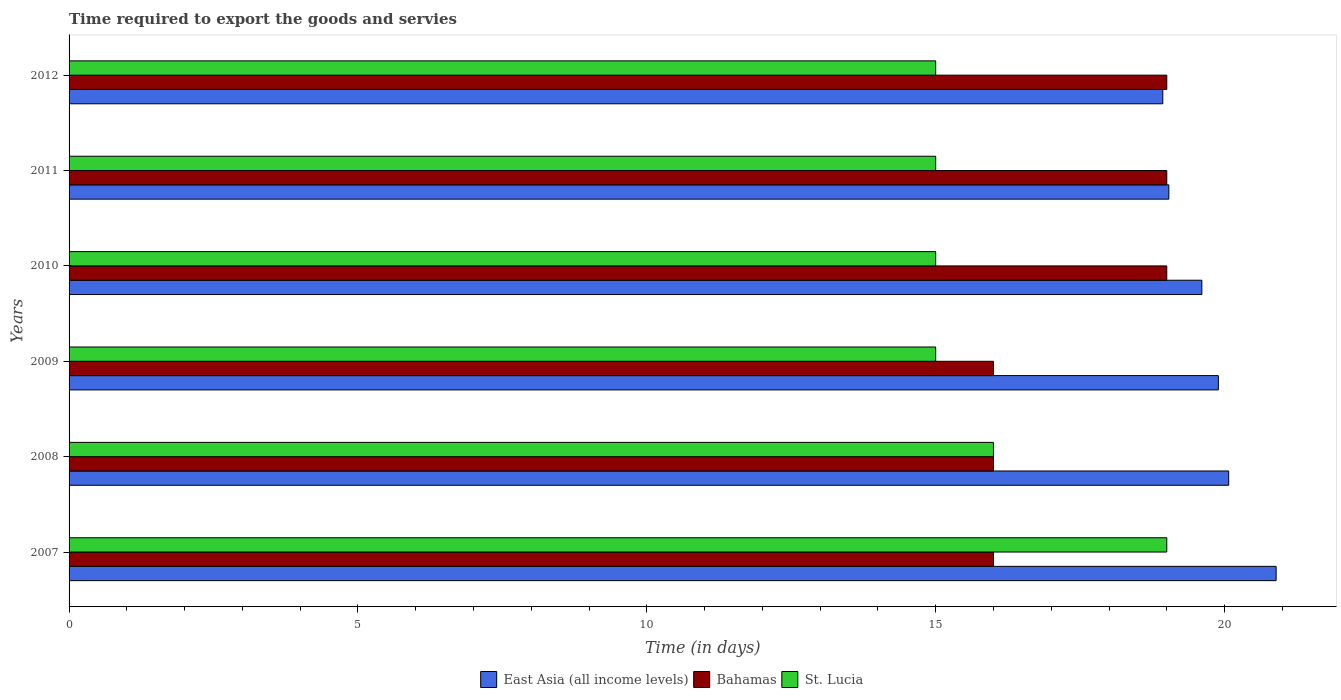How many different coloured bars are there?
Your response must be concise. 3. How many groups of bars are there?
Offer a terse response. 6. Are the number of bars per tick equal to the number of legend labels?
Your answer should be very brief. Yes. Are the number of bars on each tick of the Y-axis equal?
Provide a succinct answer. Yes. How many bars are there on the 1st tick from the bottom?
Offer a very short reply. 3. What is the label of the 6th group of bars from the top?
Keep it short and to the point. 2007. What is the number of days required to export the goods and services in St. Lucia in 2012?
Provide a short and direct response. 15. Across all years, what is the maximum number of days required to export the goods and services in St. Lucia?
Ensure brevity in your answer.  19. What is the total number of days required to export the goods and services in East Asia (all income levels) in the graph?
Your response must be concise. 118.43. What is the difference between the number of days required to export the goods and services in East Asia (all income levels) in 2010 and that in 2011?
Your response must be concise. 0.57. What is the difference between the number of days required to export the goods and services in Bahamas in 2010 and the number of days required to export the goods and services in St. Lucia in 2011?
Offer a terse response. 4. In the year 2012, what is the difference between the number of days required to export the goods and services in East Asia (all income levels) and number of days required to export the goods and services in Bahamas?
Your answer should be very brief. -0.07. In how many years, is the number of days required to export the goods and services in East Asia (all income levels) greater than 16 days?
Offer a terse response. 6. What is the ratio of the number of days required to export the goods and services in East Asia (all income levels) in 2009 to that in 2011?
Offer a terse response. 1.05. Is the number of days required to export the goods and services in East Asia (all income levels) in 2007 less than that in 2011?
Ensure brevity in your answer.  No. What is the difference between the highest and the lowest number of days required to export the goods and services in St. Lucia?
Ensure brevity in your answer.  4. Is the sum of the number of days required to export the goods and services in East Asia (all income levels) in 2010 and 2012 greater than the maximum number of days required to export the goods and services in Bahamas across all years?
Your answer should be compact. Yes. What does the 1st bar from the top in 2007 represents?
Offer a very short reply. St. Lucia. What does the 1st bar from the bottom in 2012 represents?
Provide a short and direct response. East Asia (all income levels). Is it the case that in every year, the sum of the number of days required to export the goods and services in East Asia (all income levels) and number of days required to export the goods and services in St. Lucia is greater than the number of days required to export the goods and services in Bahamas?
Keep it short and to the point. Yes. How many years are there in the graph?
Ensure brevity in your answer.  6. What is the difference between two consecutive major ticks on the X-axis?
Your answer should be very brief. 5. Does the graph contain any zero values?
Make the answer very short. No. Does the graph contain grids?
Offer a terse response. No. How are the legend labels stacked?
Offer a terse response. Horizontal. What is the title of the graph?
Ensure brevity in your answer.  Time required to export the goods and servies. What is the label or title of the X-axis?
Provide a short and direct response. Time (in days). What is the Time (in days) in East Asia (all income levels) in 2007?
Your answer should be very brief. 20.89. What is the Time (in days) in East Asia (all income levels) in 2008?
Your answer should be compact. 20.07. What is the Time (in days) in Bahamas in 2008?
Give a very brief answer. 16. What is the Time (in days) of East Asia (all income levels) in 2009?
Your response must be concise. 19.89. What is the Time (in days) in Bahamas in 2009?
Offer a terse response. 16. What is the Time (in days) in East Asia (all income levels) in 2010?
Your answer should be compact. 19.61. What is the Time (in days) of Bahamas in 2010?
Ensure brevity in your answer.  19. What is the Time (in days) of St. Lucia in 2010?
Ensure brevity in your answer.  15. What is the Time (in days) in East Asia (all income levels) in 2011?
Offer a very short reply. 19.04. What is the Time (in days) in St. Lucia in 2011?
Ensure brevity in your answer.  15. What is the Time (in days) of East Asia (all income levels) in 2012?
Offer a very short reply. 18.93. Across all years, what is the maximum Time (in days) of East Asia (all income levels)?
Keep it short and to the point. 20.89. Across all years, what is the maximum Time (in days) of Bahamas?
Keep it short and to the point. 19. Across all years, what is the maximum Time (in days) of St. Lucia?
Provide a succinct answer. 19. Across all years, what is the minimum Time (in days) in East Asia (all income levels)?
Offer a terse response. 18.93. Across all years, what is the minimum Time (in days) of Bahamas?
Offer a terse response. 16. Across all years, what is the minimum Time (in days) in St. Lucia?
Your answer should be very brief. 15. What is the total Time (in days) of East Asia (all income levels) in the graph?
Ensure brevity in your answer.  118.43. What is the total Time (in days) in Bahamas in the graph?
Your response must be concise. 105. What is the total Time (in days) in St. Lucia in the graph?
Make the answer very short. 95. What is the difference between the Time (in days) in East Asia (all income levels) in 2007 and that in 2008?
Ensure brevity in your answer.  0.82. What is the difference between the Time (in days) of Bahamas in 2007 and that in 2008?
Keep it short and to the point. 0. What is the difference between the Time (in days) in St. Lucia in 2007 and that in 2009?
Offer a terse response. 4. What is the difference between the Time (in days) in East Asia (all income levels) in 2007 and that in 2011?
Ensure brevity in your answer.  1.86. What is the difference between the Time (in days) in Bahamas in 2007 and that in 2011?
Give a very brief answer. -3. What is the difference between the Time (in days) in East Asia (all income levels) in 2007 and that in 2012?
Make the answer very short. 1.96. What is the difference between the Time (in days) of Bahamas in 2007 and that in 2012?
Keep it short and to the point. -3. What is the difference between the Time (in days) of East Asia (all income levels) in 2008 and that in 2009?
Your answer should be compact. 0.18. What is the difference between the Time (in days) of East Asia (all income levels) in 2008 and that in 2010?
Give a very brief answer. 0.46. What is the difference between the Time (in days) in St. Lucia in 2008 and that in 2010?
Provide a succinct answer. 1. What is the difference between the Time (in days) in East Asia (all income levels) in 2008 and that in 2011?
Your answer should be compact. 1.04. What is the difference between the Time (in days) in East Asia (all income levels) in 2008 and that in 2012?
Your answer should be very brief. 1.14. What is the difference between the Time (in days) in Bahamas in 2008 and that in 2012?
Your answer should be compact. -3. What is the difference between the Time (in days) of St. Lucia in 2008 and that in 2012?
Provide a short and direct response. 1. What is the difference between the Time (in days) in East Asia (all income levels) in 2009 and that in 2010?
Your response must be concise. 0.29. What is the difference between the Time (in days) in St. Lucia in 2009 and that in 2011?
Your response must be concise. 0. What is the difference between the Time (in days) of East Asia (all income levels) in 2009 and that in 2012?
Offer a terse response. 0.96. What is the difference between the Time (in days) in East Asia (all income levels) in 2010 and that in 2011?
Provide a succinct answer. 0.57. What is the difference between the Time (in days) in East Asia (all income levels) in 2010 and that in 2012?
Provide a short and direct response. 0.68. What is the difference between the Time (in days) in East Asia (all income levels) in 2011 and that in 2012?
Make the answer very short. 0.1. What is the difference between the Time (in days) in Bahamas in 2011 and that in 2012?
Offer a very short reply. 0. What is the difference between the Time (in days) of St. Lucia in 2011 and that in 2012?
Keep it short and to the point. 0. What is the difference between the Time (in days) in East Asia (all income levels) in 2007 and the Time (in days) in Bahamas in 2008?
Give a very brief answer. 4.89. What is the difference between the Time (in days) of East Asia (all income levels) in 2007 and the Time (in days) of St. Lucia in 2008?
Your answer should be compact. 4.89. What is the difference between the Time (in days) of Bahamas in 2007 and the Time (in days) of St. Lucia in 2008?
Keep it short and to the point. 0. What is the difference between the Time (in days) in East Asia (all income levels) in 2007 and the Time (in days) in Bahamas in 2009?
Your answer should be compact. 4.89. What is the difference between the Time (in days) in East Asia (all income levels) in 2007 and the Time (in days) in St. Lucia in 2009?
Give a very brief answer. 5.89. What is the difference between the Time (in days) of East Asia (all income levels) in 2007 and the Time (in days) of Bahamas in 2010?
Offer a terse response. 1.89. What is the difference between the Time (in days) in East Asia (all income levels) in 2007 and the Time (in days) in St. Lucia in 2010?
Your response must be concise. 5.89. What is the difference between the Time (in days) of East Asia (all income levels) in 2007 and the Time (in days) of Bahamas in 2011?
Your answer should be compact. 1.89. What is the difference between the Time (in days) of East Asia (all income levels) in 2007 and the Time (in days) of St. Lucia in 2011?
Give a very brief answer. 5.89. What is the difference between the Time (in days) in East Asia (all income levels) in 2007 and the Time (in days) in Bahamas in 2012?
Provide a short and direct response. 1.89. What is the difference between the Time (in days) of East Asia (all income levels) in 2007 and the Time (in days) of St. Lucia in 2012?
Your answer should be very brief. 5.89. What is the difference between the Time (in days) in East Asia (all income levels) in 2008 and the Time (in days) in Bahamas in 2009?
Offer a terse response. 4.07. What is the difference between the Time (in days) in East Asia (all income levels) in 2008 and the Time (in days) in St. Lucia in 2009?
Keep it short and to the point. 5.07. What is the difference between the Time (in days) in Bahamas in 2008 and the Time (in days) in St. Lucia in 2009?
Offer a very short reply. 1. What is the difference between the Time (in days) of East Asia (all income levels) in 2008 and the Time (in days) of Bahamas in 2010?
Keep it short and to the point. 1.07. What is the difference between the Time (in days) in East Asia (all income levels) in 2008 and the Time (in days) in St. Lucia in 2010?
Give a very brief answer. 5.07. What is the difference between the Time (in days) of Bahamas in 2008 and the Time (in days) of St. Lucia in 2010?
Keep it short and to the point. 1. What is the difference between the Time (in days) in East Asia (all income levels) in 2008 and the Time (in days) in Bahamas in 2011?
Give a very brief answer. 1.07. What is the difference between the Time (in days) in East Asia (all income levels) in 2008 and the Time (in days) in St. Lucia in 2011?
Your answer should be compact. 5.07. What is the difference between the Time (in days) in East Asia (all income levels) in 2008 and the Time (in days) in Bahamas in 2012?
Your answer should be compact. 1.07. What is the difference between the Time (in days) in East Asia (all income levels) in 2008 and the Time (in days) in St. Lucia in 2012?
Your answer should be compact. 5.07. What is the difference between the Time (in days) in East Asia (all income levels) in 2009 and the Time (in days) in Bahamas in 2010?
Make the answer very short. 0.89. What is the difference between the Time (in days) of East Asia (all income levels) in 2009 and the Time (in days) of St. Lucia in 2010?
Provide a succinct answer. 4.89. What is the difference between the Time (in days) in East Asia (all income levels) in 2009 and the Time (in days) in Bahamas in 2011?
Keep it short and to the point. 0.89. What is the difference between the Time (in days) in East Asia (all income levels) in 2009 and the Time (in days) in St. Lucia in 2011?
Provide a short and direct response. 4.89. What is the difference between the Time (in days) in East Asia (all income levels) in 2009 and the Time (in days) in Bahamas in 2012?
Offer a very short reply. 0.89. What is the difference between the Time (in days) of East Asia (all income levels) in 2009 and the Time (in days) of St. Lucia in 2012?
Offer a terse response. 4.89. What is the difference between the Time (in days) of Bahamas in 2009 and the Time (in days) of St. Lucia in 2012?
Offer a terse response. 1. What is the difference between the Time (in days) of East Asia (all income levels) in 2010 and the Time (in days) of Bahamas in 2011?
Keep it short and to the point. 0.61. What is the difference between the Time (in days) in East Asia (all income levels) in 2010 and the Time (in days) in St. Lucia in 2011?
Keep it short and to the point. 4.61. What is the difference between the Time (in days) of East Asia (all income levels) in 2010 and the Time (in days) of Bahamas in 2012?
Ensure brevity in your answer.  0.61. What is the difference between the Time (in days) in East Asia (all income levels) in 2010 and the Time (in days) in St. Lucia in 2012?
Offer a terse response. 4.61. What is the difference between the Time (in days) in East Asia (all income levels) in 2011 and the Time (in days) in Bahamas in 2012?
Make the answer very short. 0.04. What is the difference between the Time (in days) in East Asia (all income levels) in 2011 and the Time (in days) in St. Lucia in 2012?
Your answer should be compact. 4.04. What is the average Time (in days) of East Asia (all income levels) per year?
Offer a very short reply. 19.74. What is the average Time (in days) in Bahamas per year?
Your answer should be compact. 17.5. What is the average Time (in days) of St. Lucia per year?
Offer a terse response. 15.83. In the year 2007, what is the difference between the Time (in days) in East Asia (all income levels) and Time (in days) in Bahamas?
Ensure brevity in your answer.  4.89. In the year 2007, what is the difference between the Time (in days) of East Asia (all income levels) and Time (in days) of St. Lucia?
Make the answer very short. 1.89. In the year 2008, what is the difference between the Time (in days) in East Asia (all income levels) and Time (in days) in Bahamas?
Provide a short and direct response. 4.07. In the year 2008, what is the difference between the Time (in days) in East Asia (all income levels) and Time (in days) in St. Lucia?
Your response must be concise. 4.07. In the year 2009, what is the difference between the Time (in days) of East Asia (all income levels) and Time (in days) of Bahamas?
Provide a short and direct response. 3.89. In the year 2009, what is the difference between the Time (in days) of East Asia (all income levels) and Time (in days) of St. Lucia?
Provide a succinct answer. 4.89. In the year 2009, what is the difference between the Time (in days) of Bahamas and Time (in days) of St. Lucia?
Your response must be concise. 1. In the year 2010, what is the difference between the Time (in days) of East Asia (all income levels) and Time (in days) of Bahamas?
Keep it short and to the point. 0.61. In the year 2010, what is the difference between the Time (in days) of East Asia (all income levels) and Time (in days) of St. Lucia?
Your answer should be very brief. 4.61. In the year 2011, what is the difference between the Time (in days) of East Asia (all income levels) and Time (in days) of Bahamas?
Your answer should be very brief. 0.04. In the year 2011, what is the difference between the Time (in days) of East Asia (all income levels) and Time (in days) of St. Lucia?
Give a very brief answer. 4.04. In the year 2011, what is the difference between the Time (in days) in Bahamas and Time (in days) in St. Lucia?
Your answer should be very brief. 4. In the year 2012, what is the difference between the Time (in days) of East Asia (all income levels) and Time (in days) of Bahamas?
Provide a succinct answer. -0.07. In the year 2012, what is the difference between the Time (in days) in East Asia (all income levels) and Time (in days) in St. Lucia?
Give a very brief answer. 3.93. In the year 2012, what is the difference between the Time (in days) in Bahamas and Time (in days) in St. Lucia?
Your answer should be very brief. 4. What is the ratio of the Time (in days) in East Asia (all income levels) in 2007 to that in 2008?
Offer a very short reply. 1.04. What is the ratio of the Time (in days) in St. Lucia in 2007 to that in 2008?
Give a very brief answer. 1.19. What is the ratio of the Time (in days) in East Asia (all income levels) in 2007 to that in 2009?
Give a very brief answer. 1.05. What is the ratio of the Time (in days) in Bahamas in 2007 to that in 2009?
Keep it short and to the point. 1. What is the ratio of the Time (in days) in St. Lucia in 2007 to that in 2009?
Make the answer very short. 1.27. What is the ratio of the Time (in days) of East Asia (all income levels) in 2007 to that in 2010?
Offer a terse response. 1.07. What is the ratio of the Time (in days) of Bahamas in 2007 to that in 2010?
Offer a terse response. 0.84. What is the ratio of the Time (in days) in St. Lucia in 2007 to that in 2010?
Provide a succinct answer. 1.27. What is the ratio of the Time (in days) in East Asia (all income levels) in 2007 to that in 2011?
Give a very brief answer. 1.1. What is the ratio of the Time (in days) of Bahamas in 2007 to that in 2011?
Offer a terse response. 0.84. What is the ratio of the Time (in days) of St. Lucia in 2007 to that in 2011?
Offer a very short reply. 1.27. What is the ratio of the Time (in days) of East Asia (all income levels) in 2007 to that in 2012?
Keep it short and to the point. 1.1. What is the ratio of the Time (in days) of Bahamas in 2007 to that in 2012?
Make the answer very short. 0.84. What is the ratio of the Time (in days) of St. Lucia in 2007 to that in 2012?
Give a very brief answer. 1.27. What is the ratio of the Time (in days) of East Asia (all income levels) in 2008 to that in 2009?
Ensure brevity in your answer.  1.01. What is the ratio of the Time (in days) of Bahamas in 2008 to that in 2009?
Offer a terse response. 1. What is the ratio of the Time (in days) in St. Lucia in 2008 to that in 2009?
Offer a terse response. 1.07. What is the ratio of the Time (in days) in East Asia (all income levels) in 2008 to that in 2010?
Your answer should be very brief. 1.02. What is the ratio of the Time (in days) in Bahamas in 2008 to that in 2010?
Provide a succinct answer. 0.84. What is the ratio of the Time (in days) in St. Lucia in 2008 to that in 2010?
Your answer should be compact. 1.07. What is the ratio of the Time (in days) in East Asia (all income levels) in 2008 to that in 2011?
Make the answer very short. 1.05. What is the ratio of the Time (in days) in Bahamas in 2008 to that in 2011?
Your answer should be compact. 0.84. What is the ratio of the Time (in days) in St. Lucia in 2008 to that in 2011?
Keep it short and to the point. 1.07. What is the ratio of the Time (in days) of East Asia (all income levels) in 2008 to that in 2012?
Offer a very short reply. 1.06. What is the ratio of the Time (in days) in Bahamas in 2008 to that in 2012?
Offer a terse response. 0.84. What is the ratio of the Time (in days) of St. Lucia in 2008 to that in 2012?
Offer a terse response. 1.07. What is the ratio of the Time (in days) of East Asia (all income levels) in 2009 to that in 2010?
Make the answer very short. 1.01. What is the ratio of the Time (in days) of Bahamas in 2009 to that in 2010?
Provide a short and direct response. 0.84. What is the ratio of the Time (in days) in East Asia (all income levels) in 2009 to that in 2011?
Make the answer very short. 1.04. What is the ratio of the Time (in days) of Bahamas in 2009 to that in 2011?
Provide a succinct answer. 0.84. What is the ratio of the Time (in days) of St. Lucia in 2009 to that in 2011?
Keep it short and to the point. 1. What is the ratio of the Time (in days) in East Asia (all income levels) in 2009 to that in 2012?
Keep it short and to the point. 1.05. What is the ratio of the Time (in days) of Bahamas in 2009 to that in 2012?
Your answer should be compact. 0.84. What is the ratio of the Time (in days) of St. Lucia in 2009 to that in 2012?
Offer a terse response. 1. What is the ratio of the Time (in days) in Bahamas in 2010 to that in 2011?
Provide a succinct answer. 1. What is the ratio of the Time (in days) of St. Lucia in 2010 to that in 2011?
Offer a very short reply. 1. What is the ratio of the Time (in days) in East Asia (all income levels) in 2010 to that in 2012?
Give a very brief answer. 1.04. What is the ratio of the Time (in days) in Bahamas in 2011 to that in 2012?
Keep it short and to the point. 1. What is the ratio of the Time (in days) in St. Lucia in 2011 to that in 2012?
Give a very brief answer. 1. What is the difference between the highest and the second highest Time (in days) of East Asia (all income levels)?
Make the answer very short. 0.82. What is the difference between the highest and the second highest Time (in days) of Bahamas?
Provide a short and direct response. 0. What is the difference between the highest and the lowest Time (in days) of East Asia (all income levels)?
Offer a terse response. 1.96. What is the difference between the highest and the lowest Time (in days) in St. Lucia?
Your response must be concise. 4. 